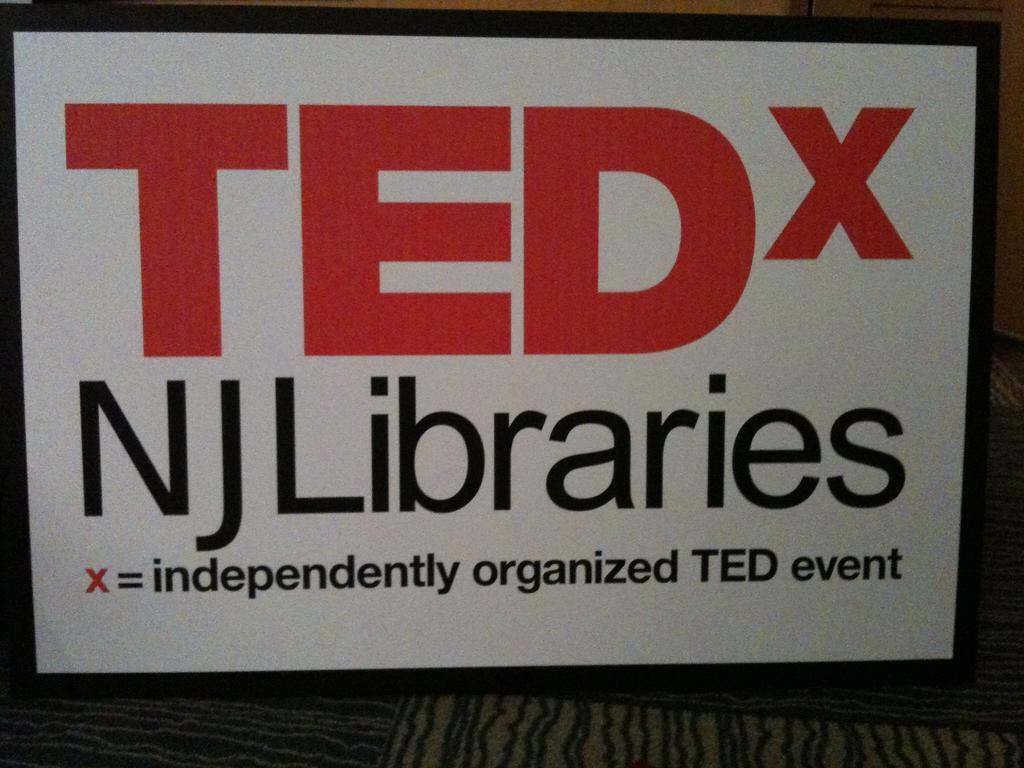<image>
Give a short and clear explanation of the subsequent image. White and black sign that says TEDx in orange. 